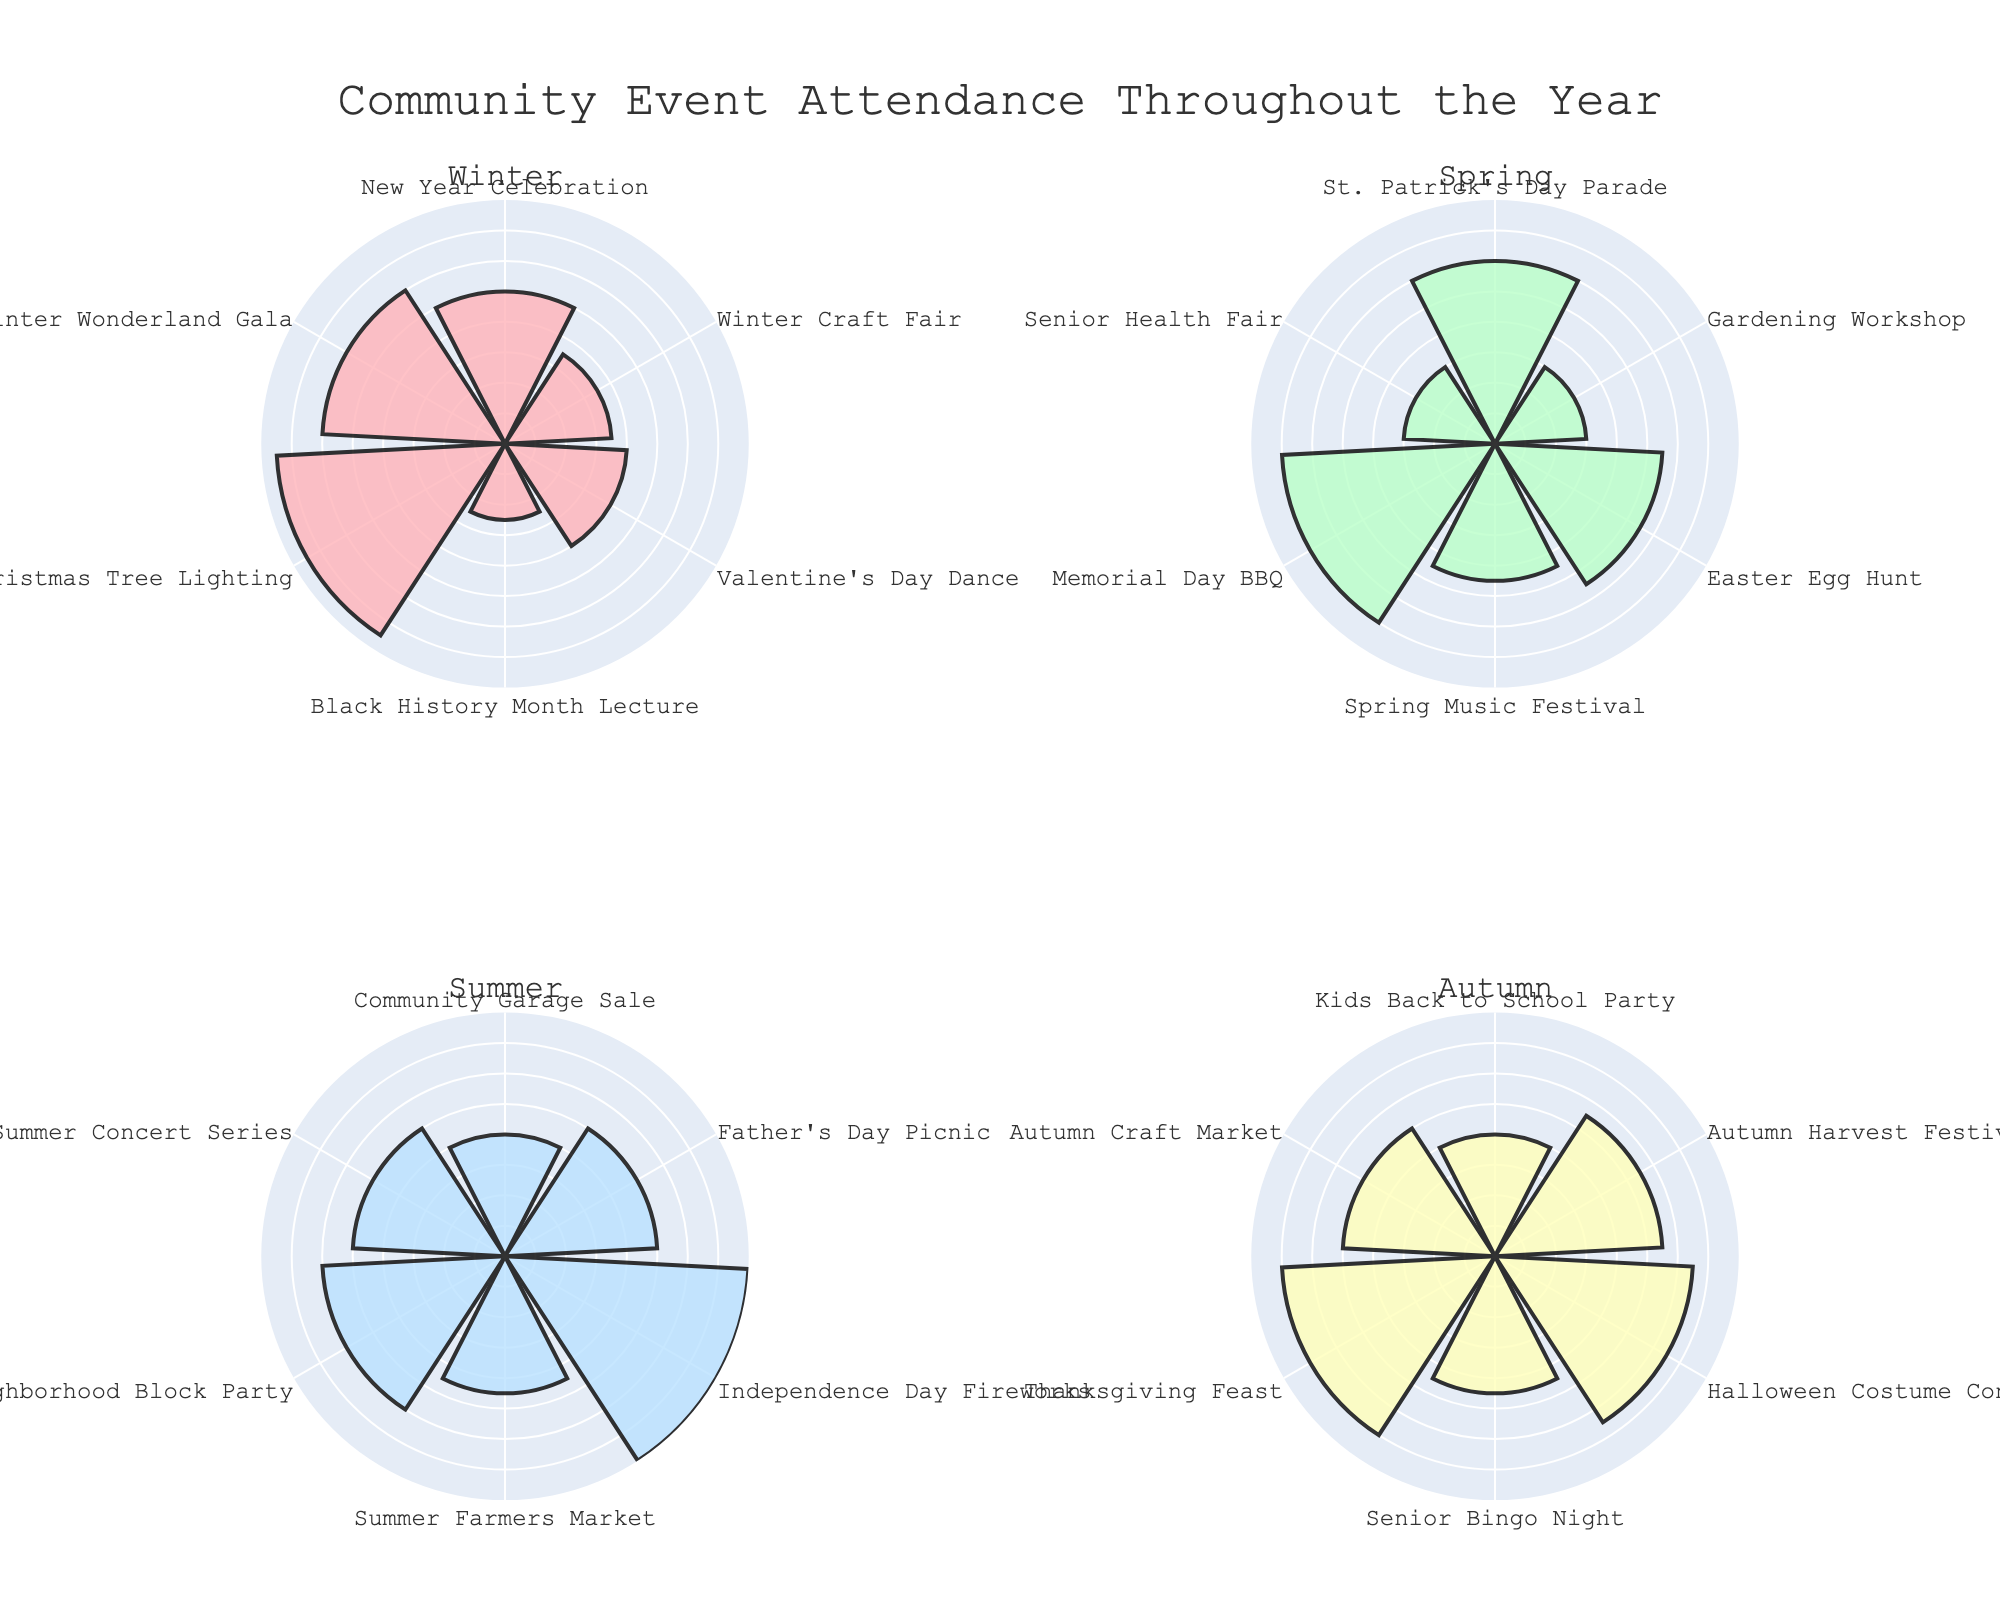Which season has the highest attendance for any single event? By inspecting the radial bars for each subplot (each season), we see that July's Independence Day Fireworks in the Summer subplot reaches 80 attendees, which is the highest attendance in any single event.
Answer: Summer What is the total number of attendees for all events in Winter? Summing up the attendees for all Winter events: Christmas Tree Lighting (75), Winter Wonderland Gala (60), New Year Celebration (50), Winter Craft Fair (35), Valentine's Day Dance (40), and Black History Month Lecture (25), gives a total of 285 attendees.
Answer: 285 Which event in Spring had the least number of attendees? Inspecting the Spring subplot, the Gardening Workshop in March had the least number of attendees with 30.
Answer: Gardening Workshop Compare the attendance of the Halloween Costume Contest and the Independence Day Fireworks. Which had more attendees and by how many? The Halloween Costume Contest had 65 attendees and the Independence Day Fireworks had 80 attendees. To find the difference: 80 - 65 = 15. Therefore, the Independence Day Fireworks had 15 more attendees.
Answer: Independence Day Fireworks by 15 Which Spring event had the highest attendance? From the Spring subplot, the Easter Egg Hunt in April had the highest attendance with 55 attendees.
Answer: Easter Egg Hunt In which season do the events tend to have the highest average attendance? To calculate the average attendance for each season:
   - Winter: (75+60+50+35+40+25)/6 = 47.5
   - Spring: (60+30+55+45)/4 = 47.5
   - Summer: (40+50+80+45+60+50)/6 = 54.17
   - Autumn: (40+55+65+45+70+50)/6 = 54.17 
   Both Summer and Autumn have the highest average attendance with 54.17.
   Therefore, the events in Summer and Autumn tend to have the highest average attendance.
Answer: Summer and Autumn Which season hosts the event with the lowest attendance and what is that event? Inspecting all the subplots, the Black History Month Lecture in February (Winter subplot) had the lowest attendance with 25 participants.
Answer: Winter, Black History Month Lecture What was the total number of attendees for the July events? The events in July are Independence Day Fireworks (80) and Summer Farmers Market (45). Summing them up: 80 + 45 = 125.
Answer: 125 How many more attendees were there at the autumn events compared to the spring events? The total attendees for Spring events are: (60 + 30 + 55 + 45) = 190 and for Autumn events are: (40 + 55 + 65 + 45 + 70 + 50) = 325. The difference is: 325 - 190 = 135.
Answer: 135 